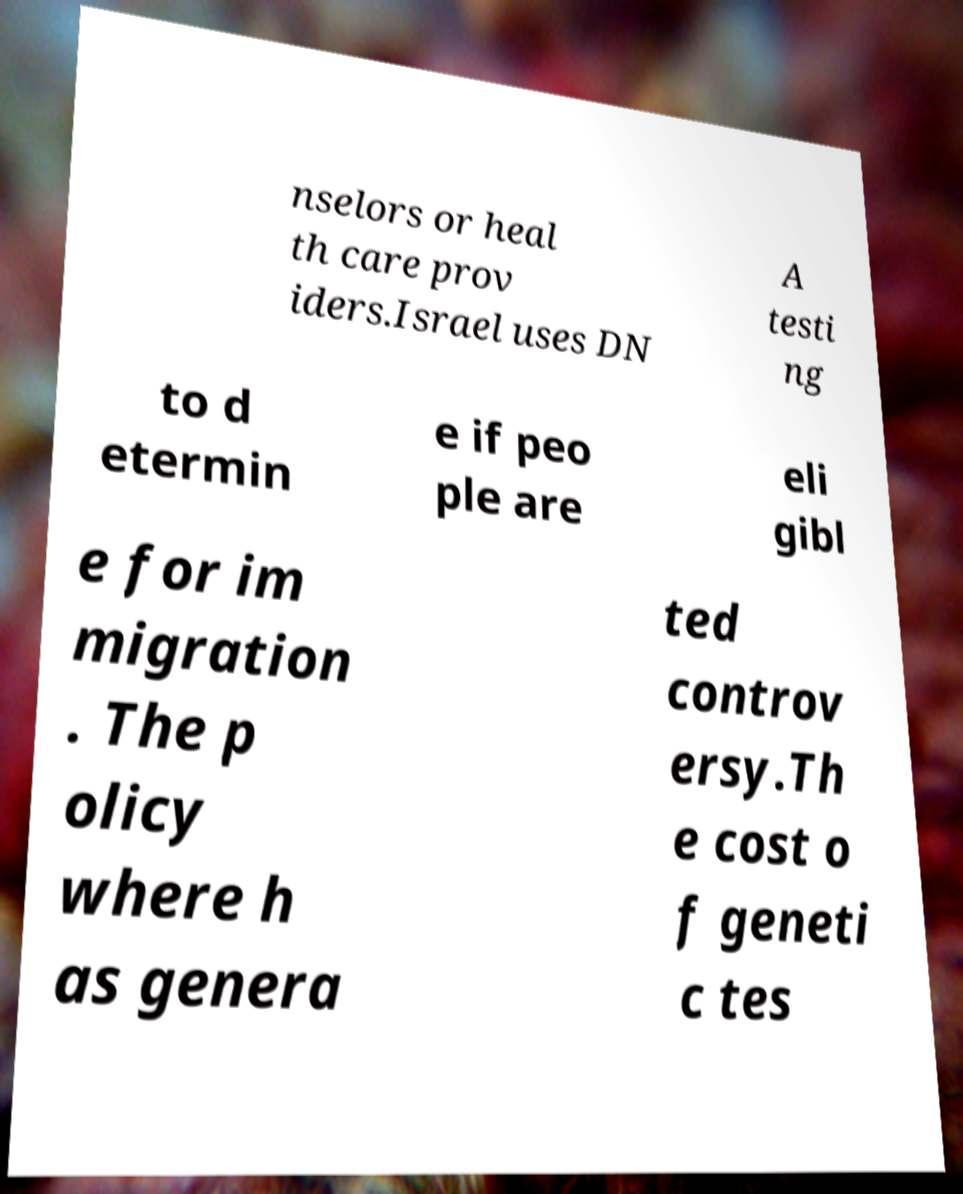Can you accurately transcribe the text from the provided image for me? nselors or heal th care prov iders.Israel uses DN A testi ng to d etermin e if peo ple are eli gibl e for im migration . The p olicy where h as genera ted controv ersy.Th e cost o f geneti c tes 